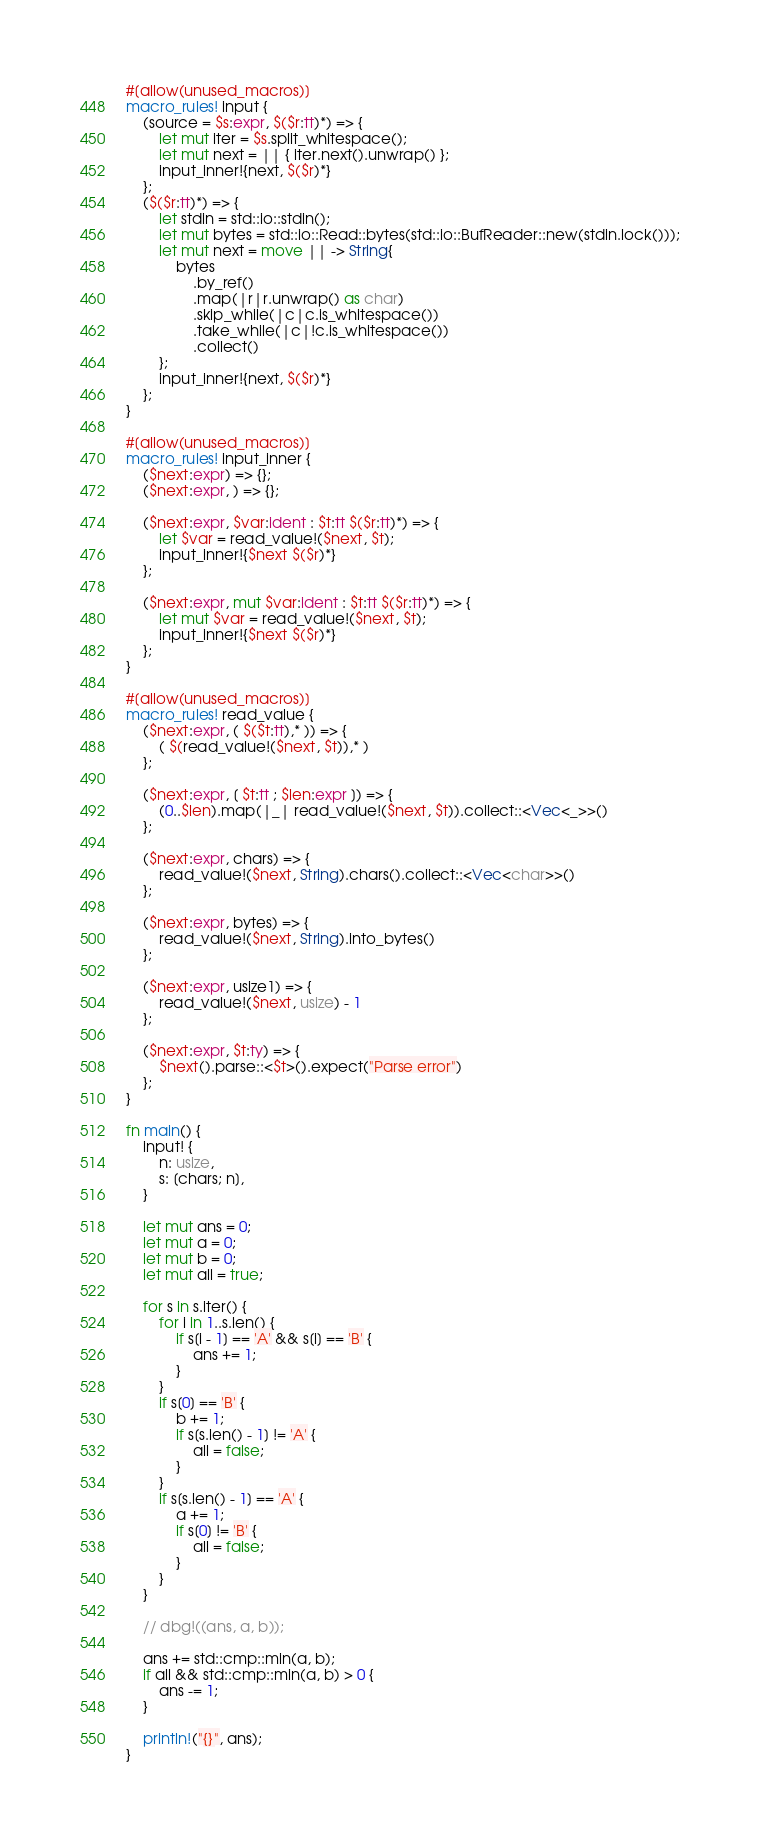<code> <loc_0><loc_0><loc_500><loc_500><_Rust_>#[allow(unused_macros)]
macro_rules! input {
    (source = $s:expr, $($r:tt)*) => {
        let mut iter = $s.split_whitespace();
        let mut next = || { iter.next().unwrap() };
        input_inner!{next, $($r)*}
    };
    ($($r:tt)*) => {
        let stdin = std::io::stdin();
        let mut bytes = std::io::Read::bytes(std::io::BufReader::new(stdin.lock()));
        let mut next = move || -> String{
            bytes
                .by_ref()
                .map(|r|r.unwrap() as char)
                .skip_while(|c|c.is_whitespace())
                .take_while(|c|!c.is_whitespace())
                .collect()
        };
        input_inner!{next, $($r)*}
    };
}

#[allow(unused_macros)]
macro_rules! input_inner {
    ($next:expr) => {};
    ($next:expr, ) => {};

    ($next:expr, $var:ident : $t:tt $($r:tt)*) => {
        let $var = read_value!($next, $t);
        input_inner!{$next $($r)*}
    };

    ($next:expr, mut $var:ident : $t:tt $($r:tt)*) => {
        let mut $var = read_value!($next, $t);
        input_inner!{$next $($r)*}
    };
}

#[allow(unused_macros)]
macro_rules! read_value {
    ($next:expr, ( $($t:tt),* )) => {
        ( $(read_value!($next, $t)),* )
    };

    ($next:expr, [ $t:tt ; $len:expr ]) => {
        (0..$len).map(|_| read_value!($next, $t)).collect::<Vec<_>>()
    };

    ($next:expr, chars) => {
        read_value!($next, String).chars().collect::<Vec<char>>()
    };

    ($next:expr, bytes) => {
        read_value!($next, String).into_bytes()
    };

    ($next:expr, usize1) => {
        read_value!($next, usize) - 1
    };

    ($next:expr, $t:ty) => {
        $next().parse::<$t>().expect("Parse error")
    };
}

fn main() {
    input! {
        n: usize,
        s: [chars; n],
    }

    let mut ans = 0;
    let mut a = 0;
    let mut b = 0;
    let mut all = true;

    for s in s.iter() {
        for i in 1..s.len() {
            if s[i - 1] == 'A' && s[i] == 'B' {
                ans += 1;
            }
        }
        if s[0] == 'B' {
            b += 1;
            if s[s.len() - 1] != 'A' {
                all = false;
            }
        }
        if s[s.len() - 1] == 'A' {
            a += 1;
            if s[0] != 'B' {
                all = false;
            }
        }
    }

    // dbg!((ans, a, b));

    ans += std::cmp::min(a, b);
    if all && std::cmp::min(a, b) > 0 {
        ans -= 1;
    }

    println!("{}", ans);
}
</code> 